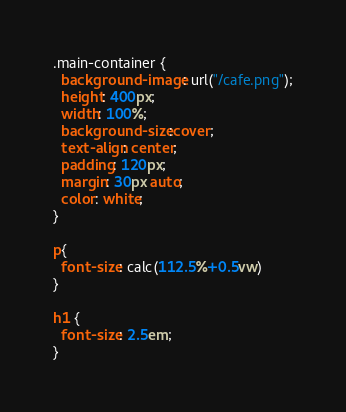<code> <loc_0><loc_0><loc_500><loc_500><_CSS_>.main-container {
  background-image: url("/cafe.png");
  height: 400px;
  width: 100%;
  background-size:cover;
  text-align: center;
  padding: 120px;
  margin: 30px auto;
  color: white;
}

p{ 
  font-size: calc(112.5%+0.5vw)
}

h1 { 
  font-size: 2.5em;
}

</code> 